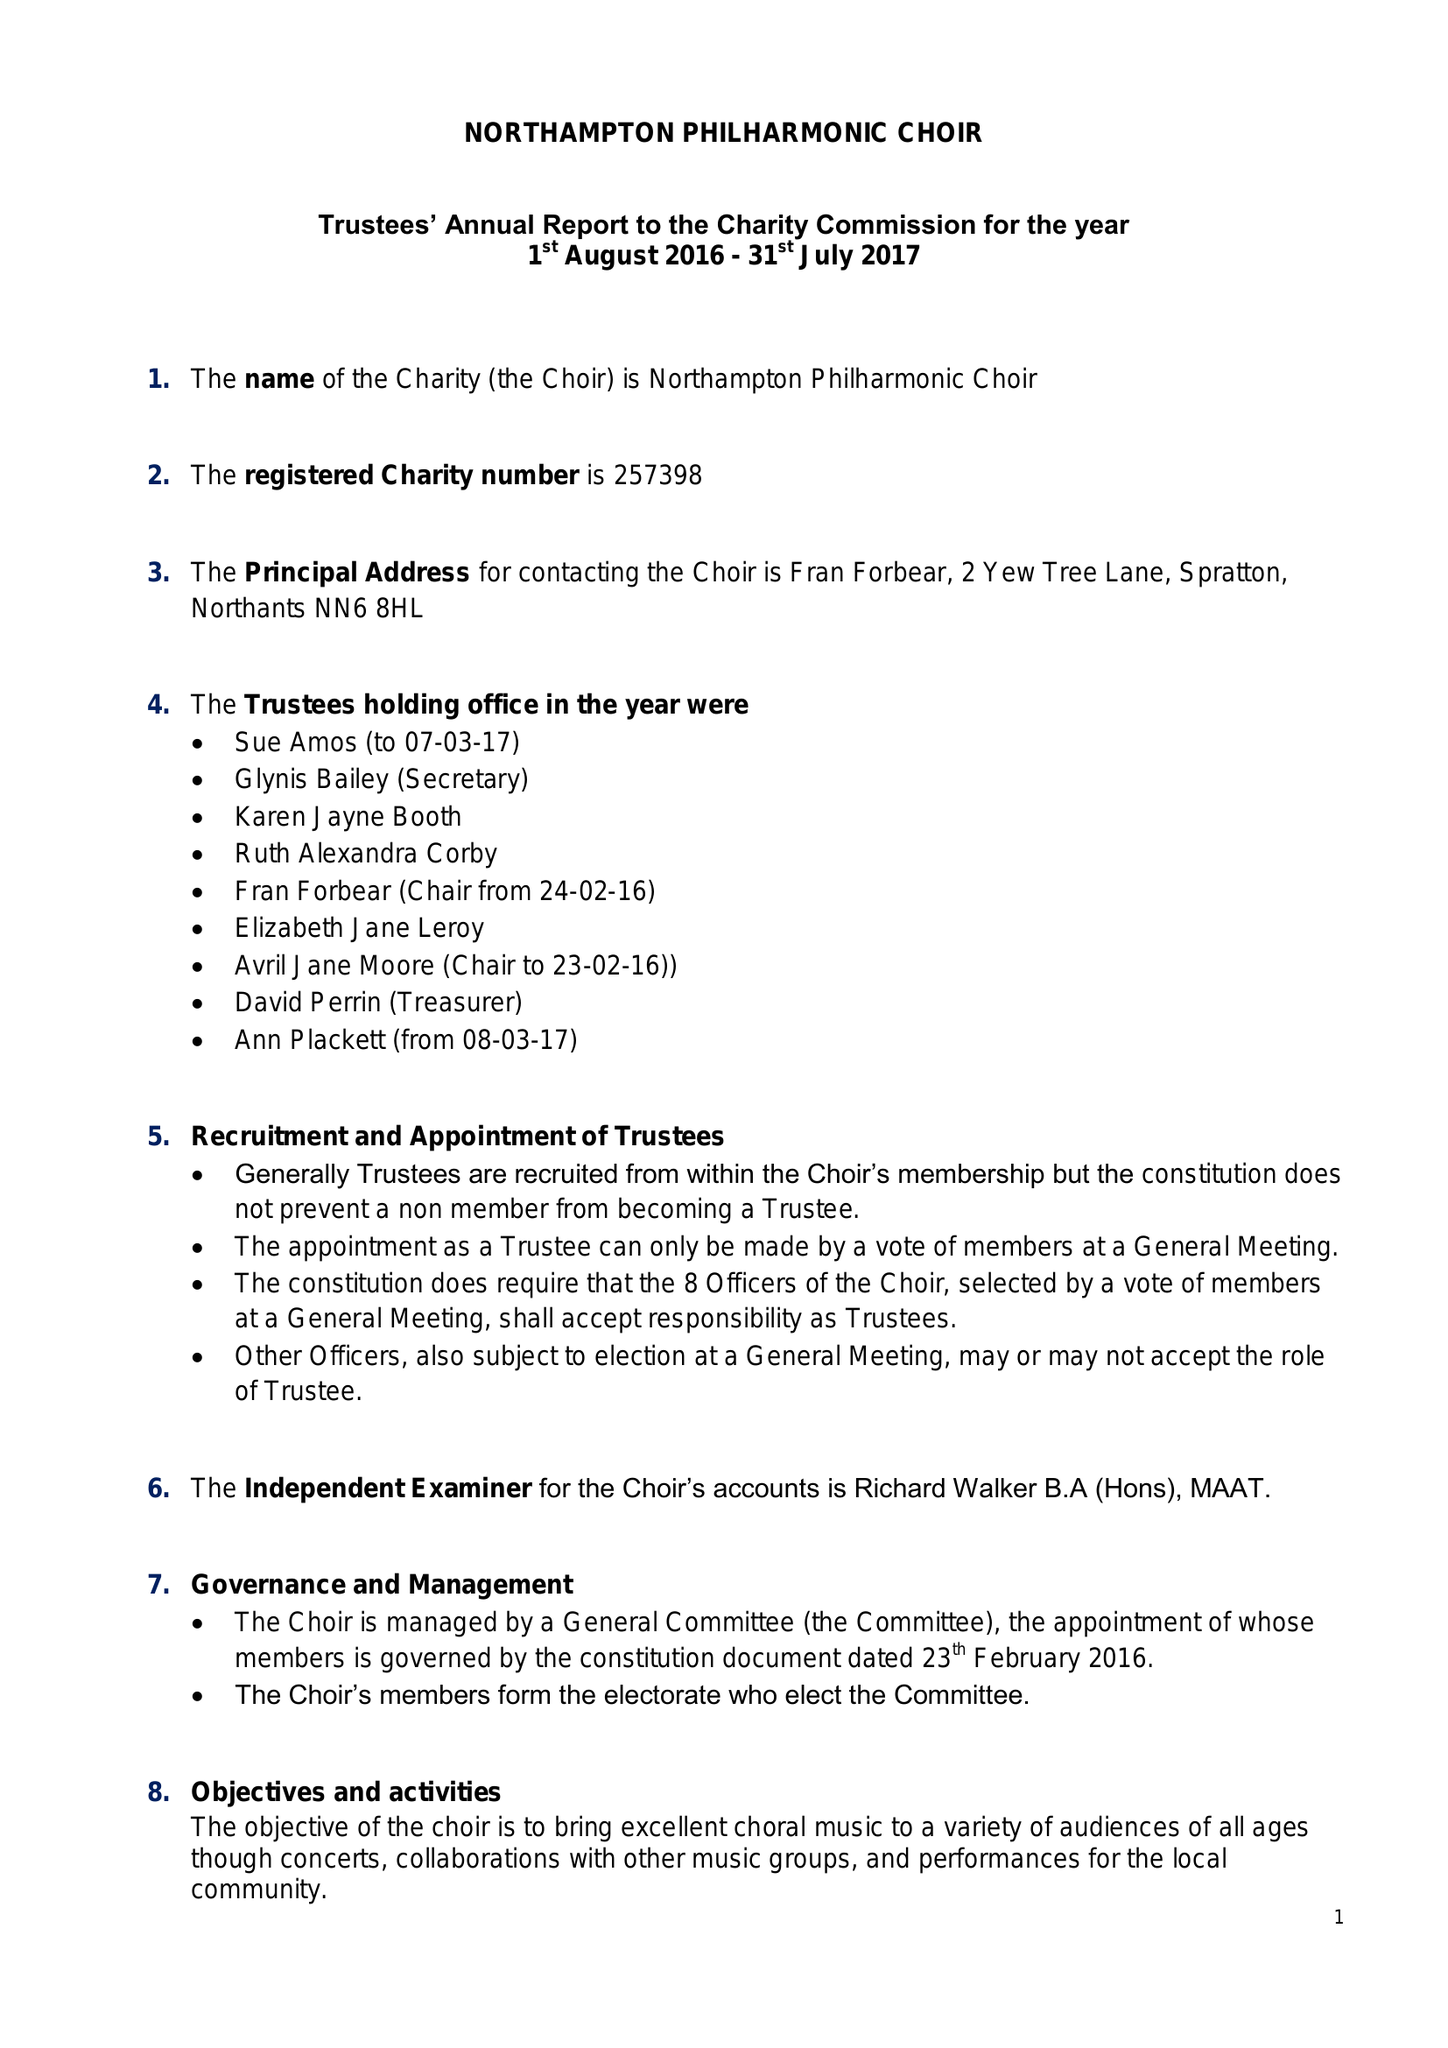What is the value for the income_annually_in_british_pounds?
Answer the question using a single word or phrase. 27323.00 